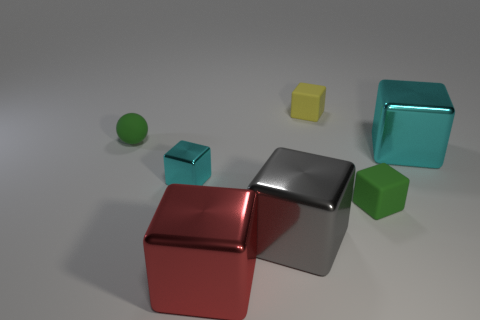Subtract all red cubes. How many cubes are left? 5 Subtract all green cubes. How many cubes are left? 5 Add 2 small green shiny cubes. How many objects exist? 9 Subtract all gray cubes. Subtract all purple balls. How many cubes are left? 5 Subtract all spheres. How many objects are left? 6 Add 1 matte cubes. How many matte cubes are left? 3 Add 7 tiny rubber objects. How many tiny rubber objects exist? 10 Subtract 0 gray balls. How many objects are left? 7 Subtract all big cubes. Subtract all big things. How many objects are left? 1 